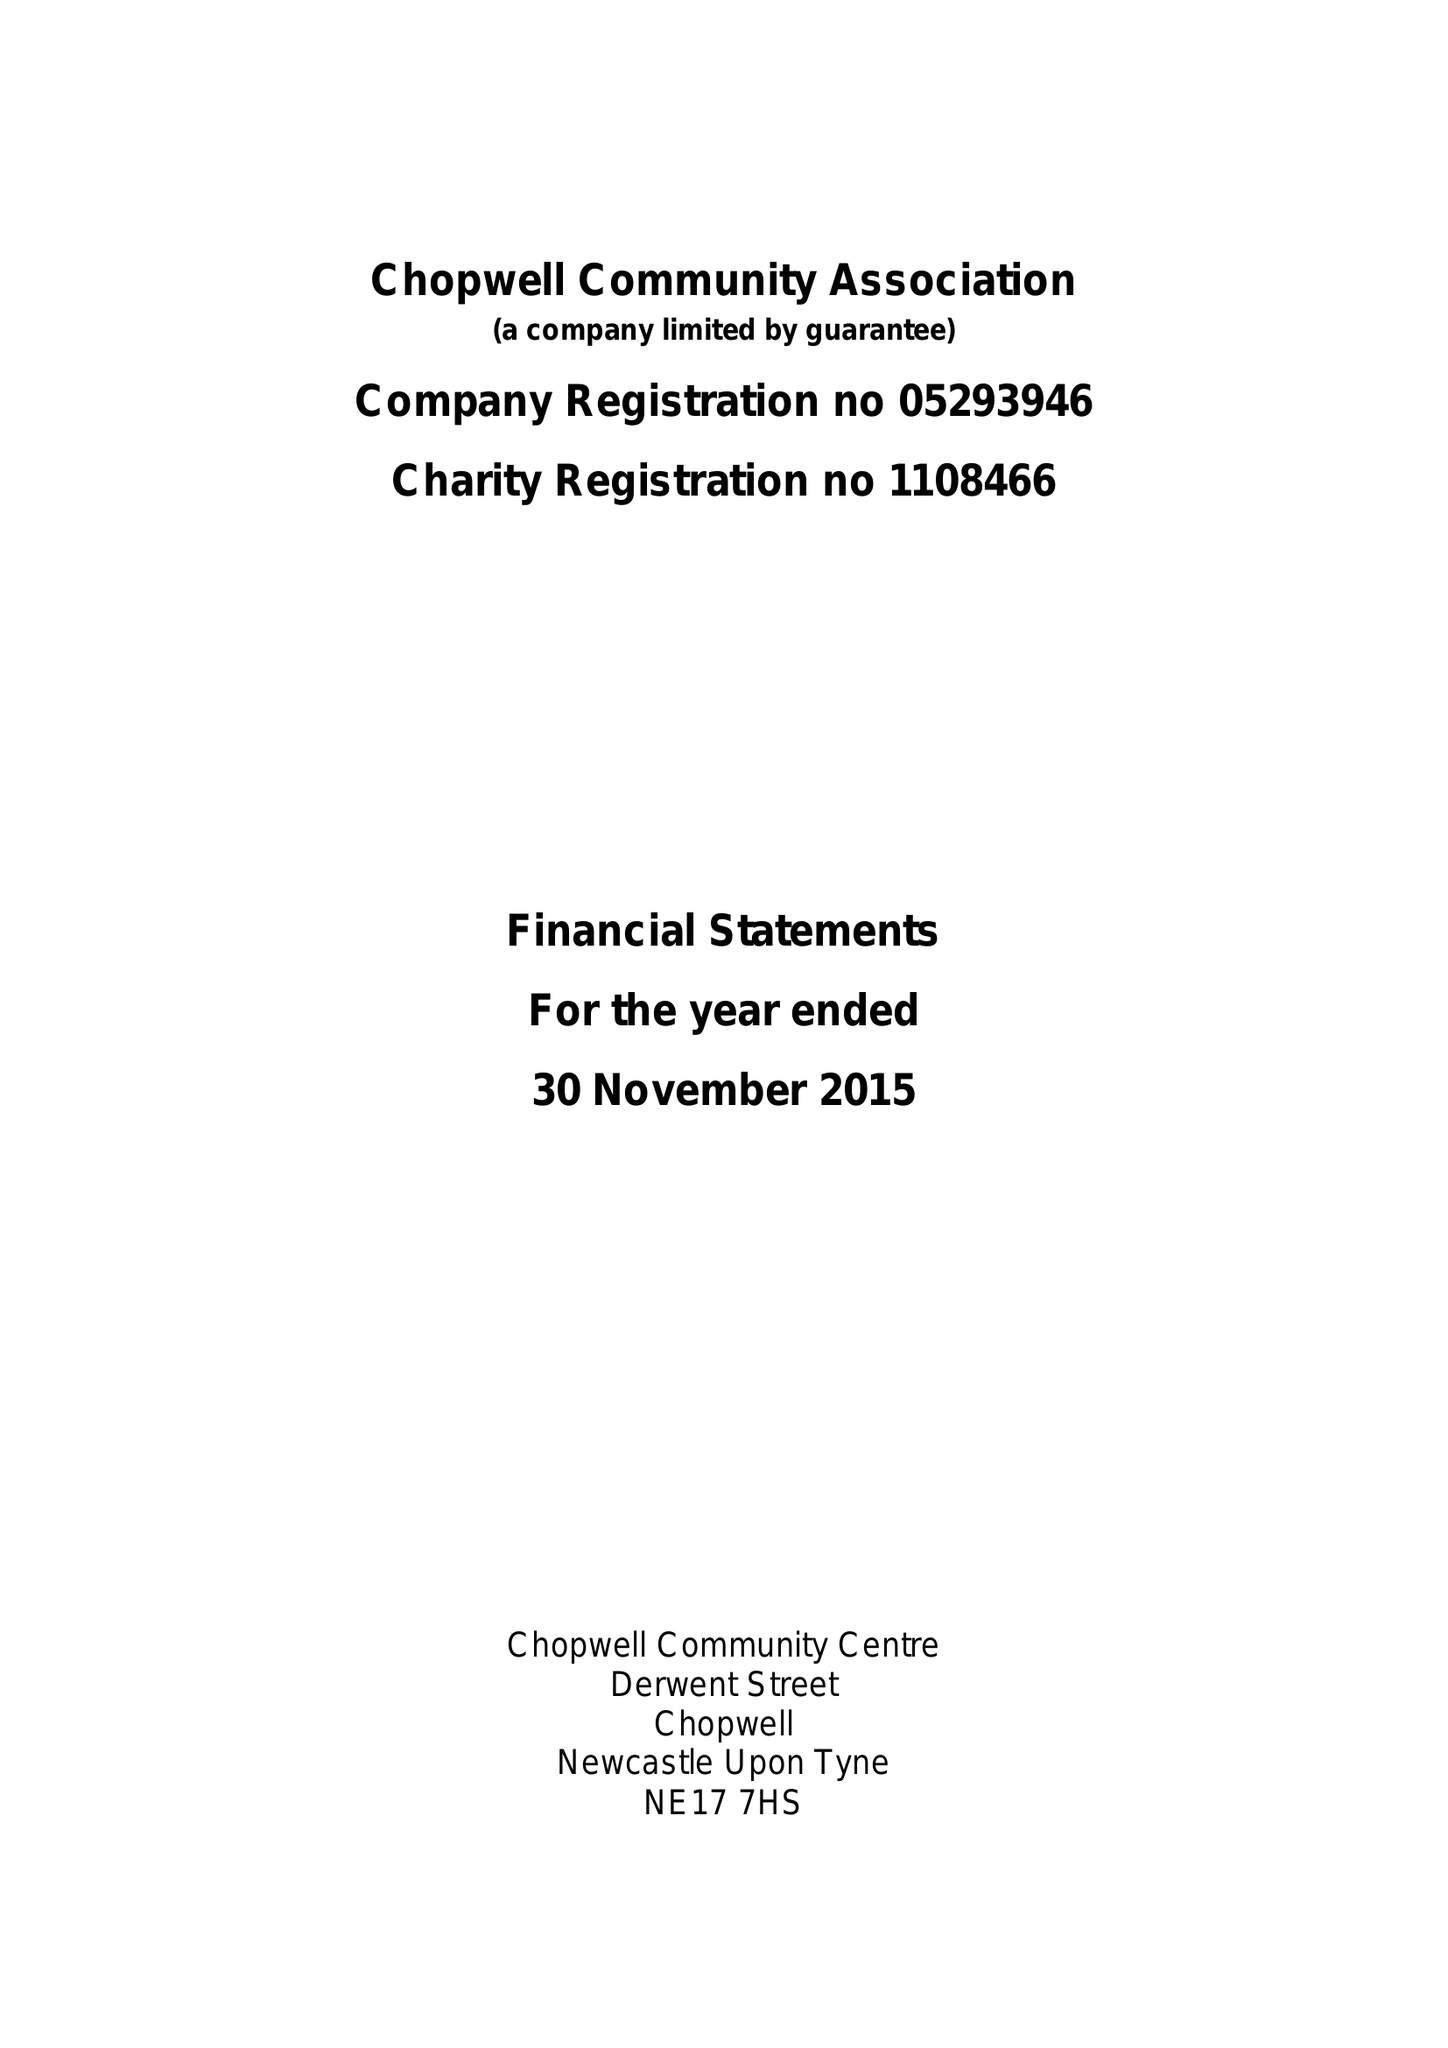What is the value for the charity_name?
Answer the question using a single word or phrase. Chopwell Community Association 